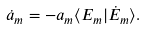<formula> <loc_0><loc_0><loc_500><loc_500>\dot { a } _ { m } = - a _ { m } \langle E _ { m } | \dot { E } _ { m } \rangle .</formula> 